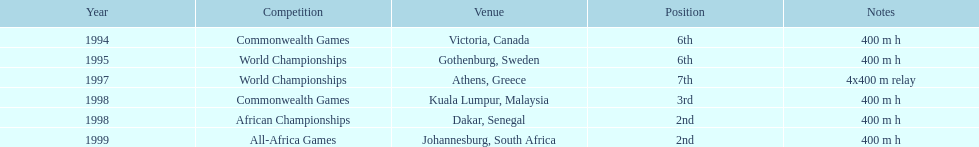How long was the relay at the 1997 world championships that ken harden ran 4x400 m relay. 